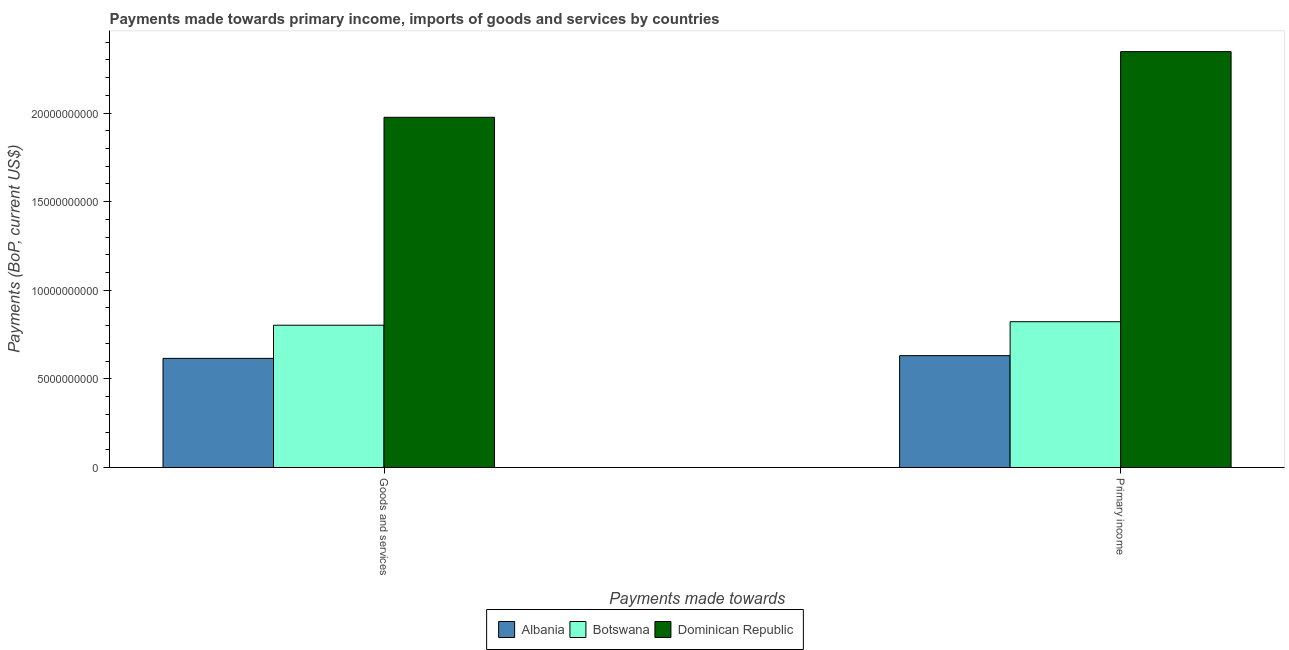How many different coloured bars are there?
Ensure brevity in your answer.  3. Are the number of bars on each tick of the X-axis equal?
Provide a succinct answer. Yes. How many bars are there on the 2nd tick from the left?
Keep it short and to the point. 3. How many bars are there on the 1st tick from the right?
Your answer should be compact. 3. What is the label of the 1st group of bars from the left?
Offer a very short reply. Goods and services. What is the payments made towards primary income in Botswana?
Your answer should be compact. 8.22e+09. Across all countries, what is the maximum payments made towards primary income?
Your answer should be compact. 2.35e+1. Across all countries, what is the minimum payments made towards primary income?
Your answer should be compact. 6.31e+09. In which country was the payments made towards goods and services maximum?
Offer a terse response. Dominican Republic. In which country was the payments made towards primary income minimum?
Make the answer very short. Albania. What is the total payments made towards primary income in the graph?
Your answer should be very brief. 3.80e+1. What is the difference between the payments made towards goods and services in Dominican Republic and that in Botswana?
Provide a short and direct response. 1.17e+1. What is the difference between the payments made towards goods and services in Botswana and the payments made towards primary income in Dominican Republic?
Give a very brief answer. -1.54e+1. What is the average payments made towards goods and services per country?
Keep it short and to the point. 1.13e+1. What is the difference between the payments made towards goods and services and payments made towards primary income in Dominican Republic?
Give a very brief answer. -3.71e+09. In how many countries, is the payments made towards goods and services greater than 5000000000 US$?
Your answer should be compact. 3. What is the ratio of the payments made towards goods and services in Botswana to that in Albania?
Your answer should be very brief. 1.3. Is the payments made towards primary income in Botswana less than that in Dominican Republic?
Ensure brevity in your answer.  Yes. What does the 1st bar from the left in Goods and services represents?
Provide a succinct answer. Albania. What does the 1st bar from the right in Primary income represents?
Keep it short and to the point. Dominican Republic. How many bars are there?
Provide a short and direct response. 6. Are all the bars in the graph horizontal?
Your answer should be compact. No. What is the difference between two consecutive major ticks on the Y-axis?
Offer a very short reply. 5.00e+09. Are the values on the major ticks of Y-axis written in scientific E-notation?
Ensure brevity in your answer.  No. Does the graph contain any zero values?
Your answer should be compact. No. How are the legend labels stacked?
Make the answer very short. Horizontal. What is the title of the graph?
Give a very brief answer. Payments made towards primary income, imports of goods and services by countries. Does "Comoros" appear as one of the legend labels in the graph?
Ensure brevity in your answer.  No. What is the label or title of the X-axis?
Provide a succinct answer. Payments made towards. What is the label or title of the Y-axis?
Make the answer very short. Payments (BoP, current US$). What is the Payments (BoP, current US$) of Albania in Goods and services?
Your answer should be very brief. 6.16e+09. What is the Payments (BoP, current US$) in Botswana in Goods and services?
Your answer should be very brief. 8.03e+09. What is the Payments (BoP, current US$) in Dominican Republic in Goods and services?
Ensure brevity in your answer.  1.98e+1. What is the Payments (BoP, current US$) of Albania in Primary income?
Your response must be concise. 6.31e+09. What is the Payments (BoP, current US$) of Botswana in Primary income?
Your answer should be very brief. 8.22e+09. What is the Payments (BoP, current US$) of Dominican Republic in Primary income?
Provide a succinct answer. 2.35e+1. Across all Payments made towards, what is the maximum Payments (BoP, current US$) in Albania?
Provide a short and direct response. 6.31e+09. Across all Payments made towards, what is the maximum Payments (BoP, current US$) in Botswana?
Keep it short and to the point. 8.22e+09. Across all Payments made towards, what is the maximum Payments (BoP, current US$) in Dominican Republic?
Ensure brevity in your answer.  2.35e+1. Across all Payments made towards, what is the minimum Payments (BoP, current US$) in Albania?
Offer a very short reply. 6.16e+09. Across all Payments made towards, what is the minimum Payments (BoP, current US$) in Botswana?
Your answer should be very brief. 8.03e+09. Across all Payments made towards, what is the minimum Payments (BoP, current US$) in Dominican Republic?
Keep it short and to the point. 1.98e+1. What is the total Payments (BoP, current US$) in Albania in the graph?
Give a very brief answer. 1.25e+1. What is the total Payments (BoP, current US$) in Botswana in the graph?
Your answer should be very brief. 1.63e+1. What is the total Payments (BoP, current US$) of Dominican Republic in the graph?
Keep it short and to the point. 4.32e+1. What is the difference between the Payments (BoP, current US$) in Albania in Goods and services and that in Primary income?
Your answer should be very brief. -1.55e+08. What is the difference between the Payments (BoP, current US$) of Botswana in Goods and services and that in Primary income?
Your answer should be compact. -1.98e+08. What is the difference between the Payments (BoP, current US$) in Dominican Republic in Goods and services and that in Primary income?
Make the answer very short. -3.71e+09. What is the difference between the Payments (BoP, current US$) of Albania in Goods and services and the Payments (BoP, current US$) of Botswana in Primary income?
Provide a short and direct response. -2.07e+09. What is the difference between the Payments (BoP, current US$) of Albania in Goods and services and the Payments (BoP, current US$) of Dominican Republic in Primary income?
Offer a very short reply. -1.73e+1. What is the difference between the Payments (BoP, current US$) of Botswana in Goods and services and the Payments (BoP, current US$) of Dominican Republic in Primary income?
Your response must be concise. -1.54e+1. What is the average Payments (BoP, current US$) of Albania per Payments made towards?
Make the answer very short. 6.23e+09. What is the average Payments (BoP, current US$) of Botswana per Payments made towards?
Your answer should be compact. 8.13e+09. What is the average Payments (BoP, current US$) in Dominican Republic per Payments made towards?
Give a very brief answer. 2.16e+1. What is the difference between the Payments (BoP, current US$) of Albania and Payments (BoP, current US$) of Botswana in Goods and services?
Your response must be concise. -1.87e+09. What is the difference between the Payments (BoP, current US$) of Albania and Payments (BoP, current US$) of Dominican Republic in Goods and services?
Make the answer very short. -1.36e+1. What is the difference between the Payments (BoP, current US$) in Botswana and Payments (BoP, current US$) in Dominican Republic in Goods and services?
Your answer should be compact. -1.17e+1. What is the difference between the Payments (BoP, current US$) of Albania and Payments (BoP, current US$) of Botswana in Primary income?
Provide a short and direct response. -1.91e+09. What is the difference between the Payments (BoP, current US$) in Albania and Payments (BoP, current US$) in Dominican Republic in Primary income?
Your answer should be very brief. -1.72e+1. What is the difference between the Payments (BoP, current US$) in Botswana and Payments (BoP, current US$) in Dominican Republic in Primary income?
Your answer should be very brief. -1.52e+1. What is the ratio of the Payments (BoP, current US$) in Albania in Goods and services to that in Primary income?
Ensure brevity in your answer.  0.98. What is the ratio of the Payments (BoP, current US$) in Botswana in Goods and services to that in Primary income?
Offer a very short reply. 0.98. What is the ratio of the Payments (BoP, current US$) of Dominican Republic in Goods and services to that in Primary income?
Keep it short and to the point. 0.84. What is the difference between the highest and the second highest Payments (BoP, current US$) in Albania?
Offer a terse response. 1.55e+08. What is the difference between the highest and the second highest Payments (BoP, current US$) of Botswana?
Provide a succinct answer. 1.98e+08. What is the difference between the highest and the second highest Payments (BoP, current US$) of Dominican Republic?
Make the answer very short. 3.71e+09. What is the difference between the highest and the lowest Payments (BoP, current US$) of Albania?
Your response must be concise. 1.55e+08. What is the difference between the highest and the lowest Payments (BoP, current US$) of Botswana?
Offer a very short reply. 1.98e+08. What is the difference between the highest and the lowest Payments (BoP, current US$) in Dominican Republic?
Offer a very short reply. 3.71e+09. 